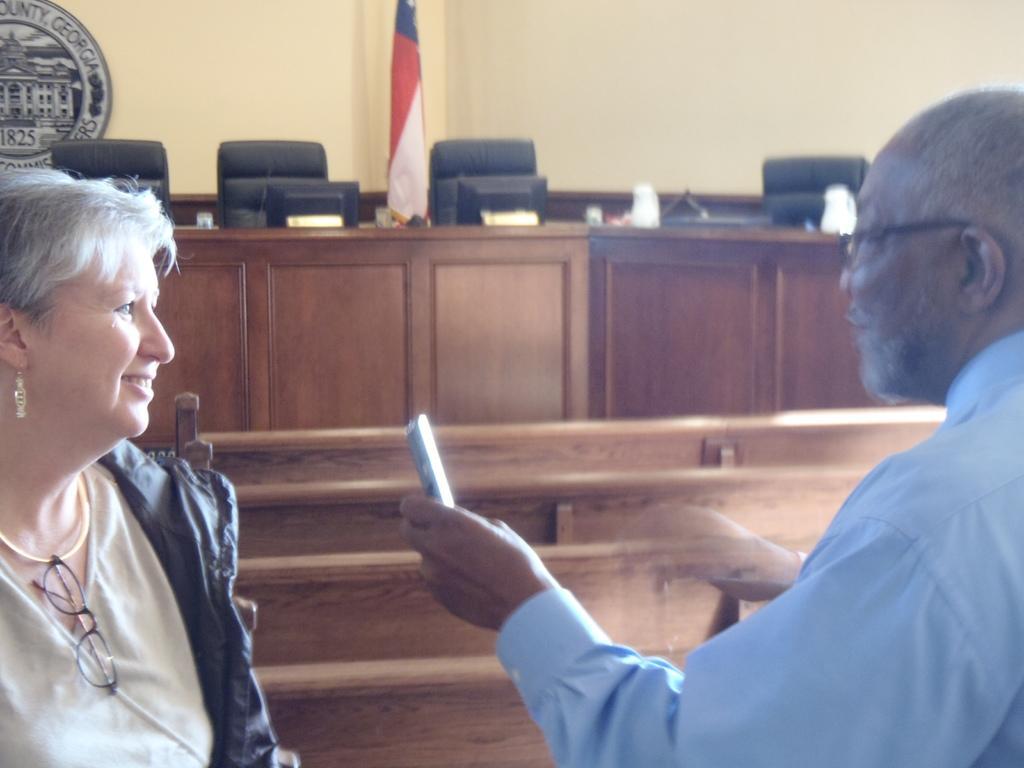Can you describe this image briefly? In this picture we can see a woman and a man. Here we can see some chairs and these are the monitors. On the background there is a wall and this is flag. 